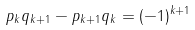<formula> <loc_0><loc_0><loc_500><loc_500>p _ { k } q _ { k + 1 } - p _ { k + 1 } q _ { k } = ( - 1 ) ^ { k + 1 }</formula> 